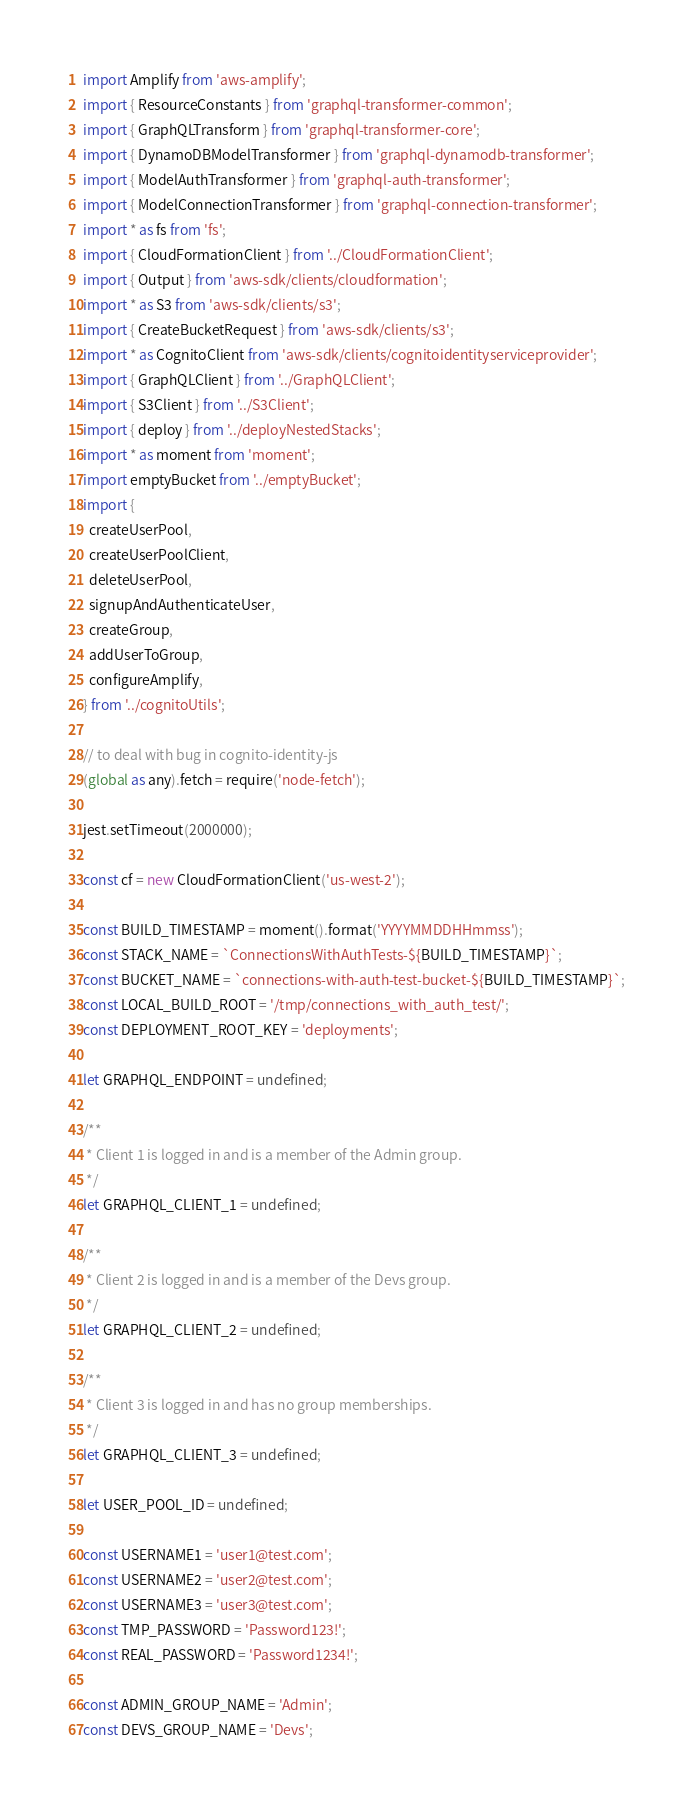Convert code to text. <code><loc_0><loc_0><loc_500><loc_500><_TypeScript_>import Amplify from 'aws-amplify';
import { ResourceConstants } from 'graphql-transformer-common';
import { GraphQLTransform } from 'graphql-transformer-core';
import { DynamoDBModelTransformer } from 'graphql-dynamodb-transformer';
import { ModelAuthTransformer } from 'graphql-auth-transformer';
import { ModelConnectionTransformer } from 'graphql-connection-transformer';
import * as fs from 'fs';
import { CloudFormationClient } from '../CloudFormationClient';
import { Output } from 'aws-sdk/clients/cloudformation';
import * as S3 from 'aws-sdk/clients/s3';
import { CreateBucketRequest } from 'aws-sdk/clients/s3';
import * as CognitoClient from 'aws-sdk/clients/cognitoidentityserviceprovider';
import { GraphQLClient } from '../GraphQLClient';
import { S3Client } from '../S3Client';
import { deploy } from '../deployNestedStacks';
import * as moment from 'moment';
import emptyBucket from '../emptyBucket';
import {
  createUserPool,
  createUserPoolClient,
  deleteUserPool,
  signupAndAuthenticateUser,
  createGroup,
  addUserToGroup,
  configureAmplify,
} from '../cognitoUtils';

// to deal with bug in cognito-identity-js
(global as any).fetch = require('node-fetch');

jest.setTimeout(2000000);

const cf = new CloudFormationClient('us-west-2');

const BUILD_TIMESTAMP = moment().format('YYYYMMDDHHmmss');
const STACK_NAME = `ConnectionsWithAuthTests-${BUILD_TIMESTAMP}`;
const BUCKET_NAME = `connections-with-auth-test-bucket-${BUILD_TIMESTAMP}`;
const LOCAL_BUILD_ROOT = '/tmp/connections_with_auth_test/';
const DEPLOYMENT_ROOT_KEY = 'deployments';

let GRAPHQL_ENDPOINT = undefined;

/**
 * Client 1 is logged in and is a member of the Admin group.
 */
let GRAPHQL_CLIENT_1 = undefined;

/**
 * Client 2 is logged in and is a member of the Devs group.
 */
let GRAPHQL_CLIENT_2 = undefined;

/**
 * Client 3 is logged in and has no group memberships.
 */
let GRAPHQL_CLIENT_3 = undefined;

let USER_POOL_ID = undefined;

const USERNAME1 = 'user1@test.com';
const USERNAME2 = 'user2@test.com';
const USERNAME3 = 'user3@test.com';
const TMP_PASSWORD = 'Password123!';
const REAL_PASSWORD = 'Password1234!';

const ADMIN_GROUP_NAME = 'Admin';
const DEVS_GROUP_NAME = 'Devs';</code> 